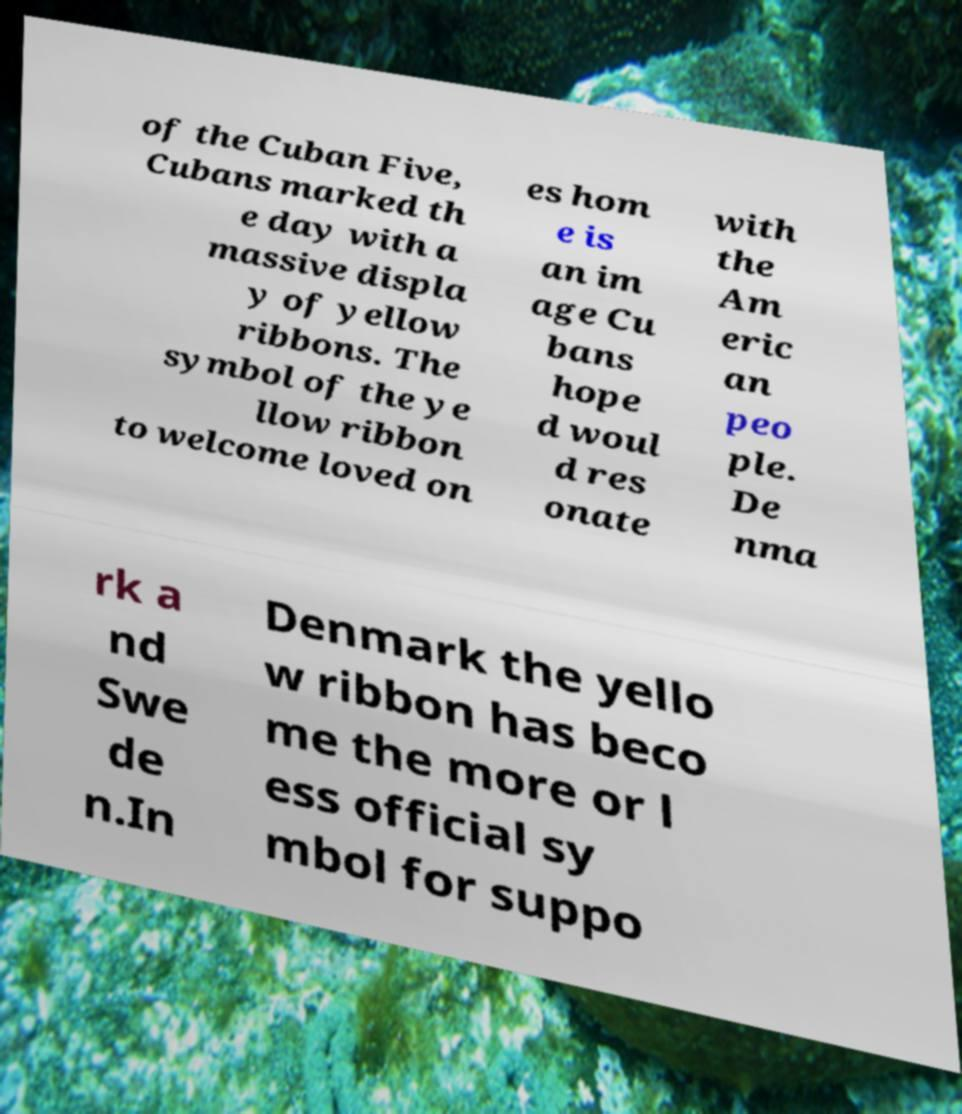Could you extract and type out the text from this image? of the Cuban Five, Cubans marked th e day with a massive displa y of yellow ribbons. The symbol of the ye llow ribbon to welcome loved on es hom e is an im age Cu bans hope d woul d res onate with the Am eric an peo ple. De nma rk a nd Swe de n.In Denmark the yello w ribbon has beco me the more or l ess official sy mbol for suppo 